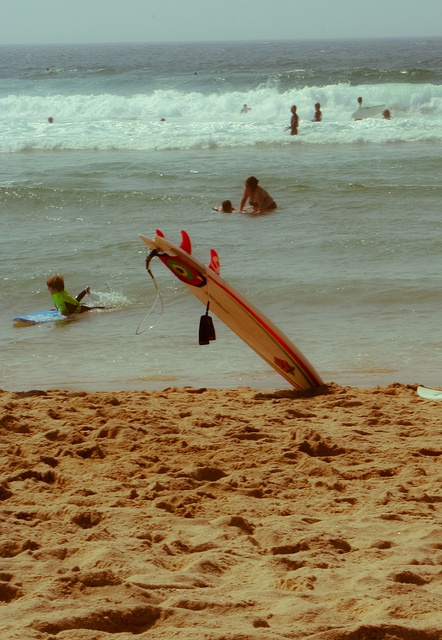Describe the objects in this image and their specific colors. I can see surfboard in lightblue, brown, maroon, and gray tones, people in lightblue, darkgreen, black, gray, and maroon tones, people in lightblue, maroon, black, and gray tones, surfboard in lightblue, darkgray, and gray tones, and people in lightblue, maroon, darkgray, and gray tones in this image. 